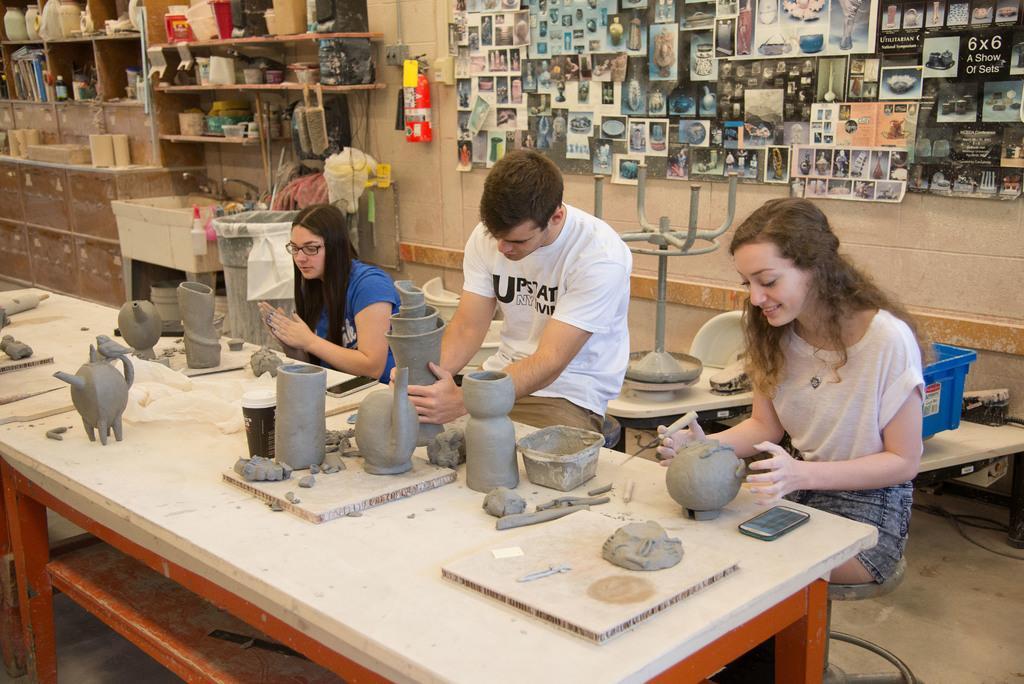Could you give a brief overview of what you see in this image? In this picture there are two women and men who are sitting on the chair. There people are making pots with mud. There is a phone, cup and pot making objects on the table. There is a mud and white slab is visible. There are many images on the board. A fire extinguisher, bin, bottle, wash basin are visible. There is a jar, bottle, many boxes are kept in a shelf. 